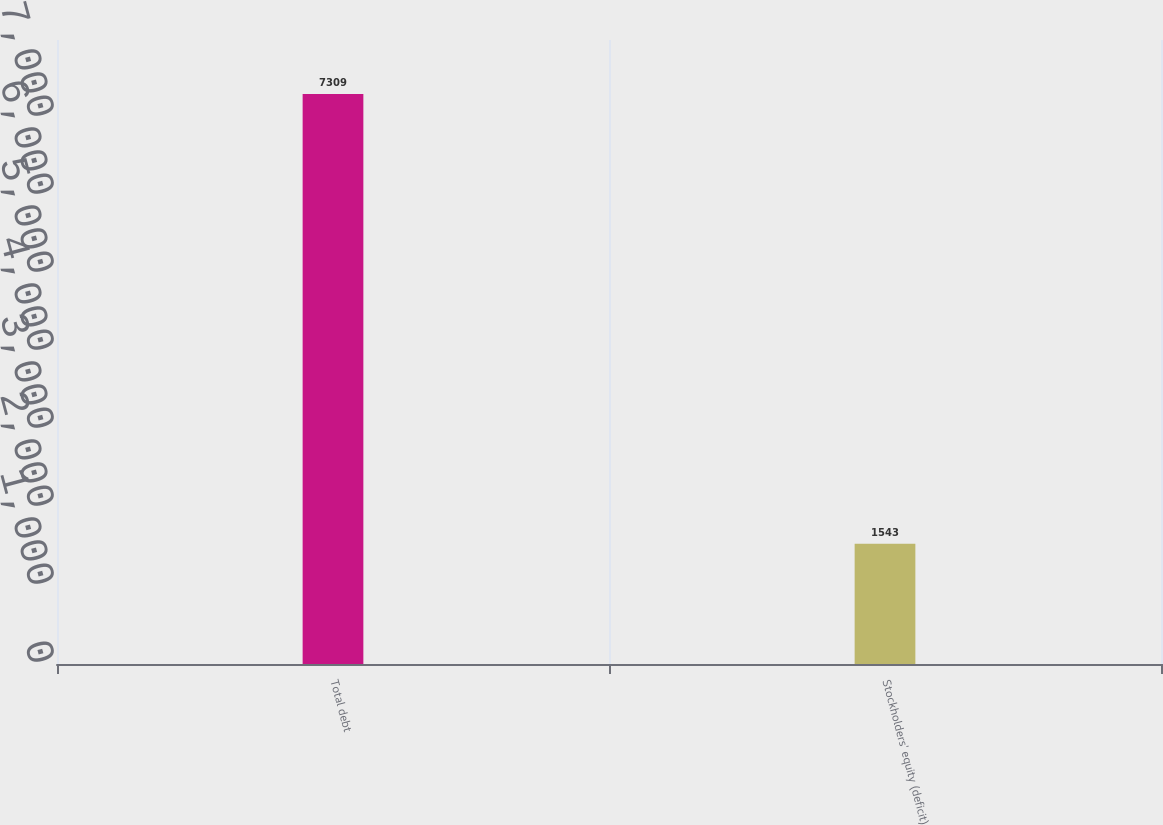<chart> <loc_0><loc_0><loc_500><loc_500><bar_chart><fcel>Total debt<fcel>Stockholders' equity (deficit)<nl><fcel>7309<fcel>1543<nl></chart> 